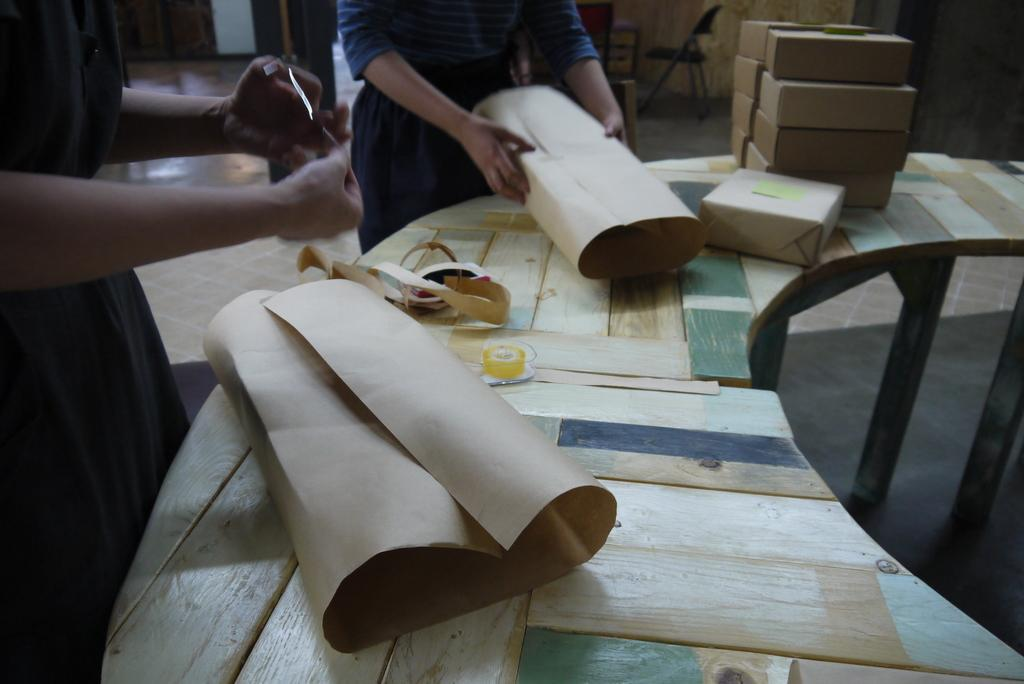What objects are on the table in the image? There are packing boxes on a table in the image. How many people are involved in packing the boxes? Two women are involved in packing the boxes. What material is one woman using for packing? One woman is using a brown sheet for packing. What is the other woman doing to the boxes? The other woman is applying plaster to the boxes. What card is the woman using to apply plaster to the boxes? There is no card present in the image; the woman is applying plaster directly to the boxes. 